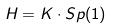<formula> <loc_0><loc_0><loc_500><loc_500>H = K \cdot S p ( 1 )</formula> 